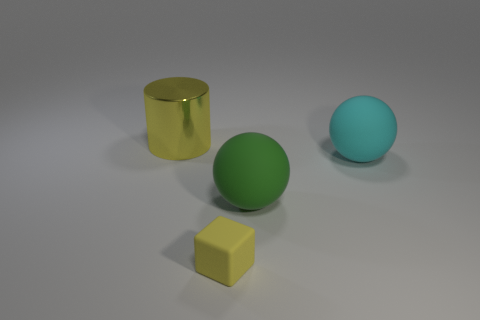What can you infer about the material of the objects? Based on the reflections and surface textures, the cylinder appears to be metal, possibly gold-toned, due to its reflective and shiny surface. The green sphere has a matte finish suggesting a surface that diffuses light, which could be a painted or plastic material. Similarly, the large cyan sphere has a matte appearance, implying a non-reflective surface, which also could be plastic or perhaps rubber. 